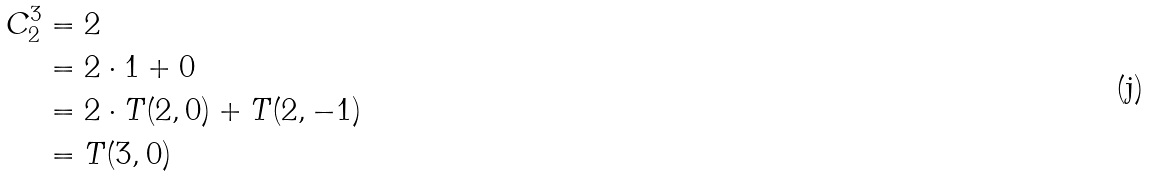<formula> <loc_0><loc_0><loc_500><loc_500>C _ { 2 } ^ { 3 } & = 2 \\ & = 2 \cdot 1 + 0 \\ & = 2 \cdot T ( 2 , 0 ) + T ( 2 , - 1 ) \\ & = T ( 3 , 0 )</formula> 